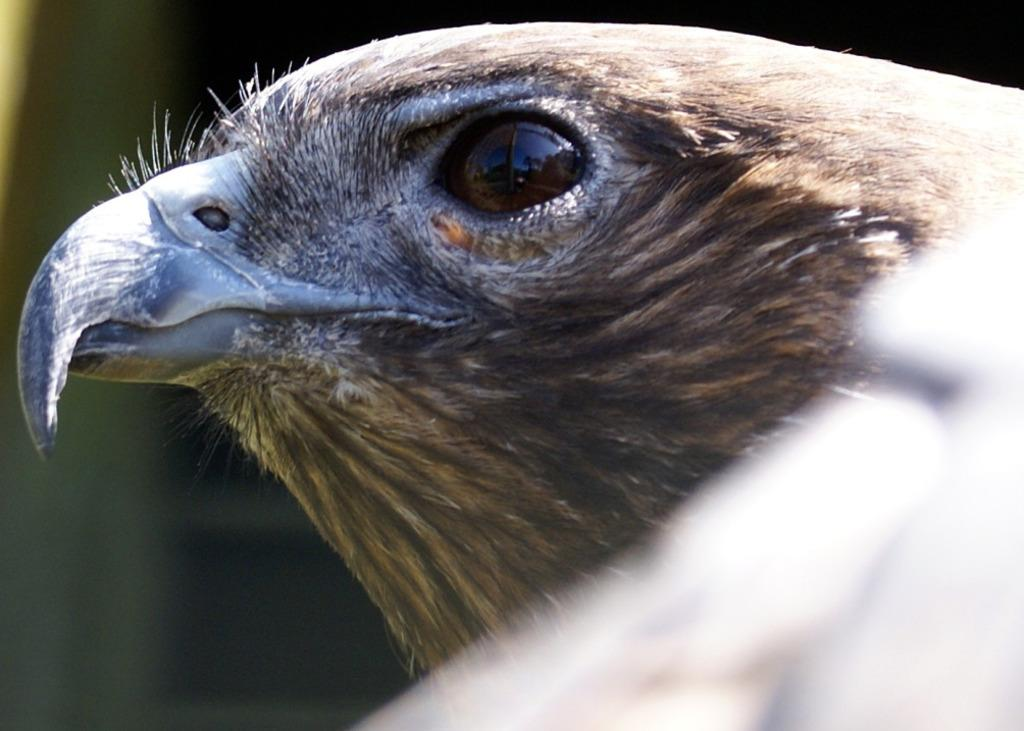What type of animal is in the image? There is a bird in the image. What features can be observed on the bird's face? The bird has a beak and an eye. Does the bird have any other facial features? Yes, the bird has a mouth. What color is the bird in the image? The bird is in brown color. How many insects are crawling on the bird's beak in the image? There are no insects present in the image, so it is not possible to determine how many might be crawling on the bird's beak. 